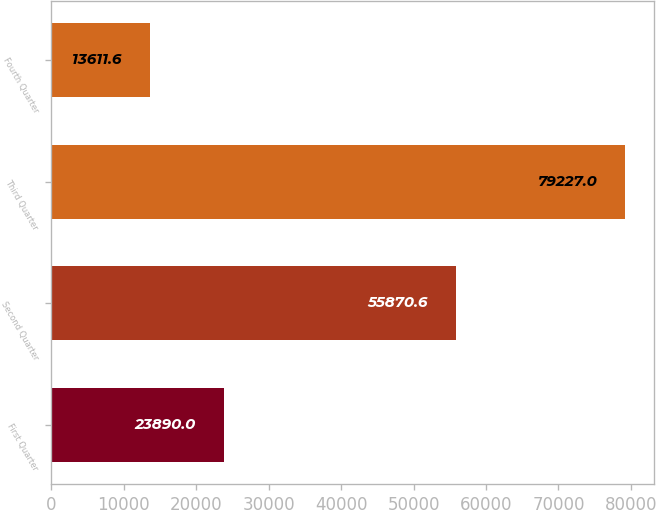Convert chart to OTSL. <chart><loc_0><loc_0><loc_500><loc_500><bar_chart><fcel>First Quarter<fcel>Second Quarter<fcel>Third Quarter<fcel>Fourth Quarter<nl><fcel>23890<fcel>55870.6<fcel>79227<fcel>13611.6<nl></chart> 